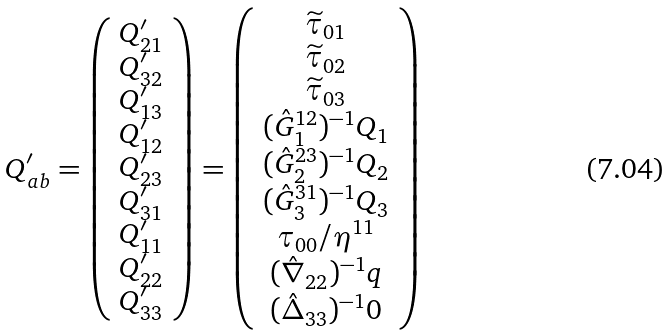<formula> <loc_0><loc_0><loc_500><loc_500>Q ^ { \prime } _ { a b } = \left ( \begin{array} { c } Q ^ { \prime } _ { 2 1 } \\ Q ^ { \prime } _ { 3 2 } \\ Q ^ { \prime } _ { 1 3 } \\ Q ^ { \prime } _ { 1 2 } \\ Q ^ { \prime } _ { 2 3 } \\ Q ^ { \prime } _ { 3 1 } \\ Q ^ { \prime } _ { 1 1 } \\ Q ^ { \prime } _ { 2 2 } \\ Q ^ { \prime } _ { 3 3 } \\ \end{array} \right ) = \left ( \begin{array} { c } \widetilde { \tau } _ { 0 1 } \\ \widetilde { \tau } _ { 0 2 } \\ \widetilde { \tau } _ { 0 3 } \\ ( \hat { G } _ { 1 } ^ { 1 2 } ) ^ { - 1 } Q _ { 1 } \\ ( \hat { G } _ { 2 } ^ { 2 3 } ) ^ { - 1 } Q _ { 2 } \\ ( \hat { G } _ { 3 } ^ { 3 1 } ) ^ { - 1 } Q _ { 3 } \\ \tau _ { 0 0 } / \eta ^ { 1 1 } \\ ( \hat { \nabla } _ { 2 2 } ) ^ { - 1 } q \\ ( \hat { \Delta } _ { 3 3 } ) ^ { - 1 } 0 \\ \end{array} \right )</formula> 